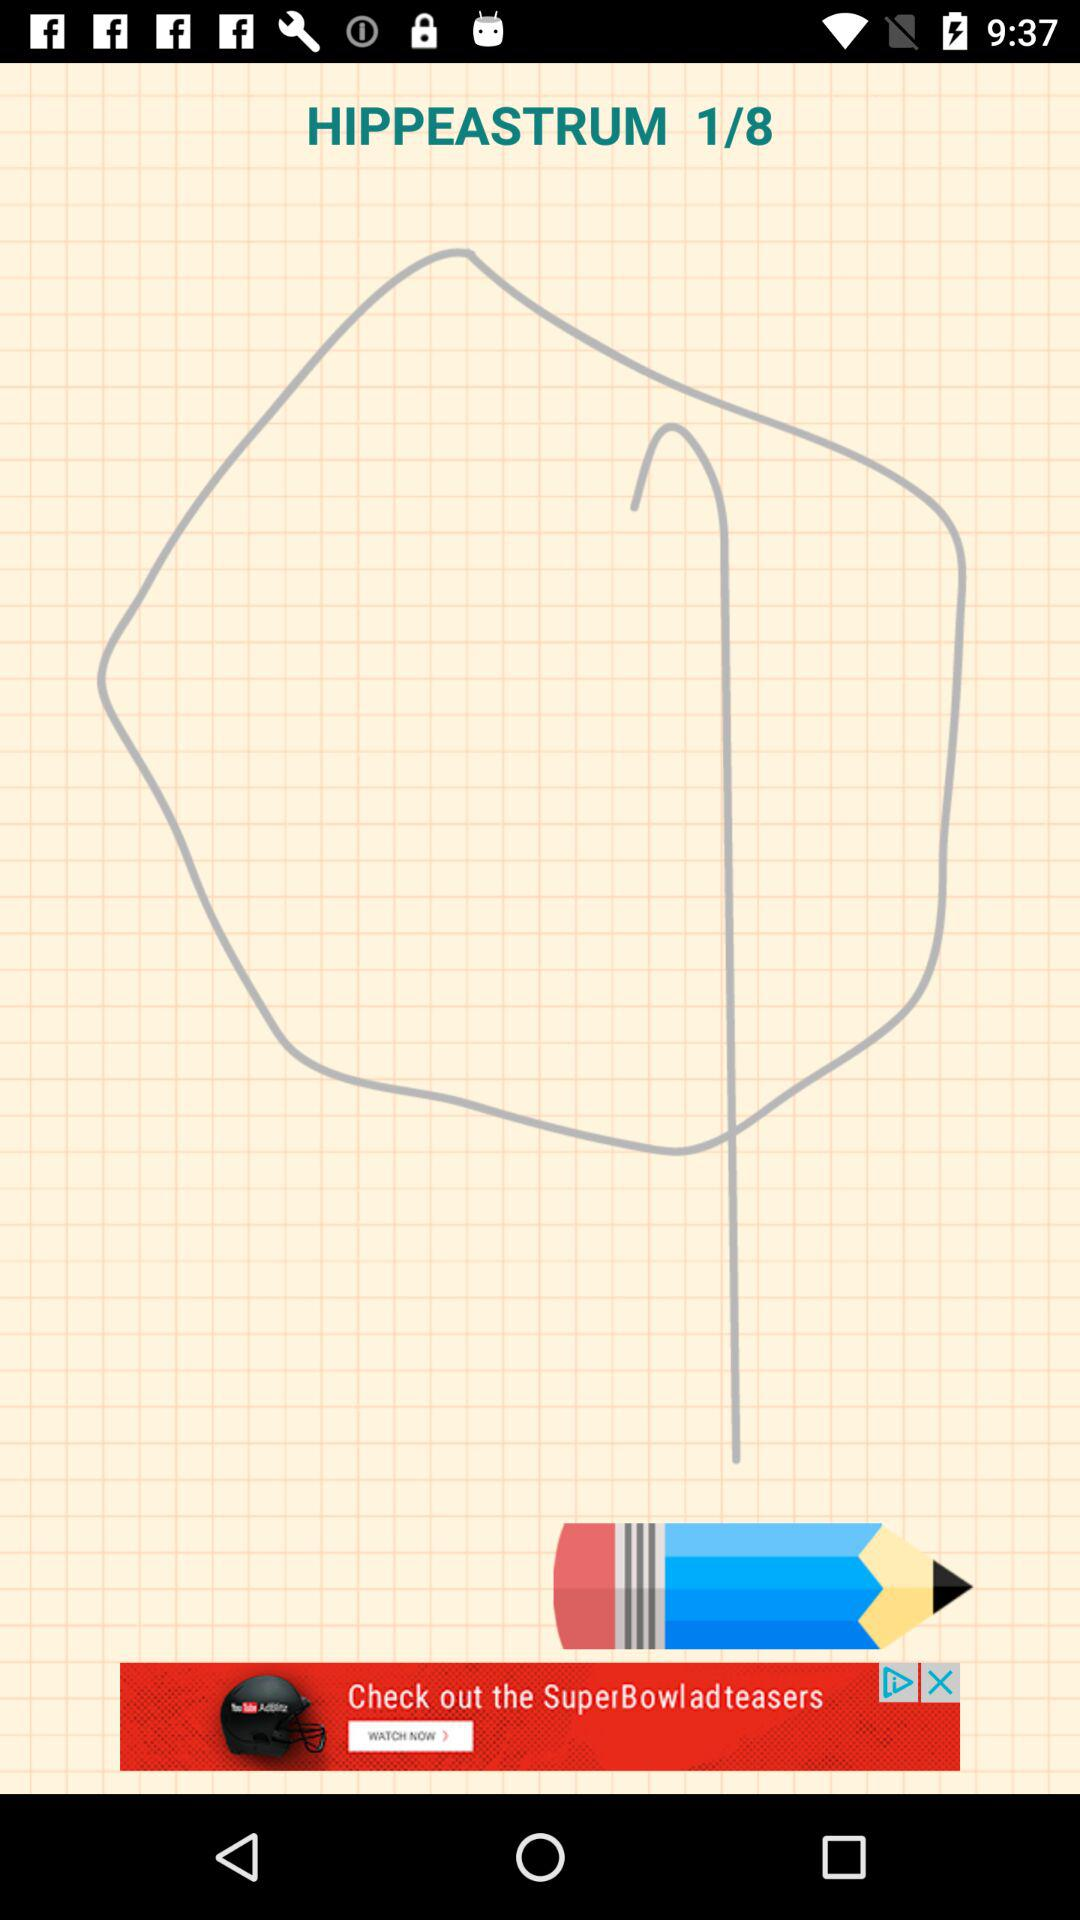What is the name of the application?
When the provided information is insufficient, respond with <no answer>. <no answer> 